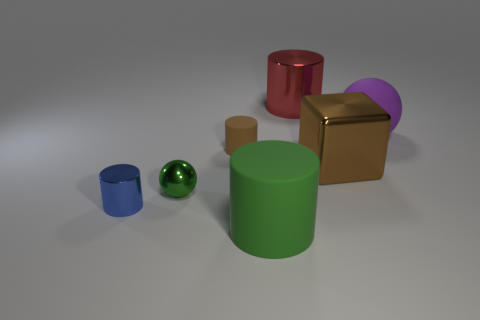Is the shiny ball the same color as the big rubber cylinder?
Your response must be concise. Yes. Are there more spheres that are on the left side of the red shiny object than big yellow matte balls?
Provide a short and direct response. Yes. How many small brown things are on the left side of the green object on the left side of the brown matte cylinder?
Offer a terse response. 0. Is the large object behind the purple rubber sphere made of the same material as the small cylinder to the left of the small metallic ball?
Provide a short and direct response. Yes. There is a object that is the same color as the shiny block; what is it made of?
Offer a terse response. Rubber. What number of brown metallic things have the same shape as the large red metal object?
Provide a succinct answer. 0. Are the large ball and the green thing that is on the right side of the small brown thing made of the same material?
Provide a short and direct response. Yes. There is a blue cylinder that is the same size as the green metal thing; what material is it?
Provide a succinct answer. Metal. Are there any rubber spheres that have the same size as the metal cube?
Make the answer very short. Yes. There is a green metal thing that is the same size as the blue metallic thing; what shape is it?
Make the answer very short. Sphere. 